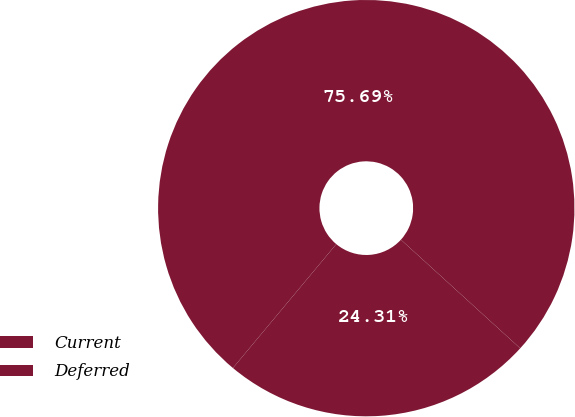Convert chart to OTSL. <chart><loc_0><loc_0><loc_500><loc_500><pie_chart><fcel>Current<fcel>Deferred<nl><fcel>24.31%<fcel>75.69%<nl></chart> 